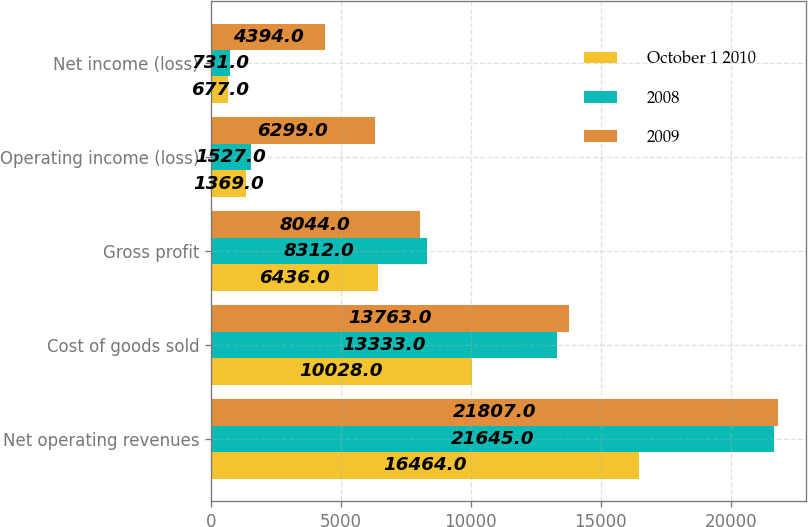<chart> <loc_0><loc_0><loc_500><loc_500><stacked_bar_chart><ecel><fcel>Net operating revenues<fcel>Cost of goods sold<fcel>Gross profit<fcel>Operating income (loss)<fcel>Net income (loss)<nl><fcel>October 1 2010<fcel>16464<fcel>10028<fcel>6436<fcel>1369<fcel>677<nl><fcel>2008<fcel>21645<fcel>13333<fcel>8312<fcel>1527<fcel>731<nl><fcel>2009<fcel>21807<fcel>13763<fcel>8044<fcel>6299<fcel>4394<nl></chart> 